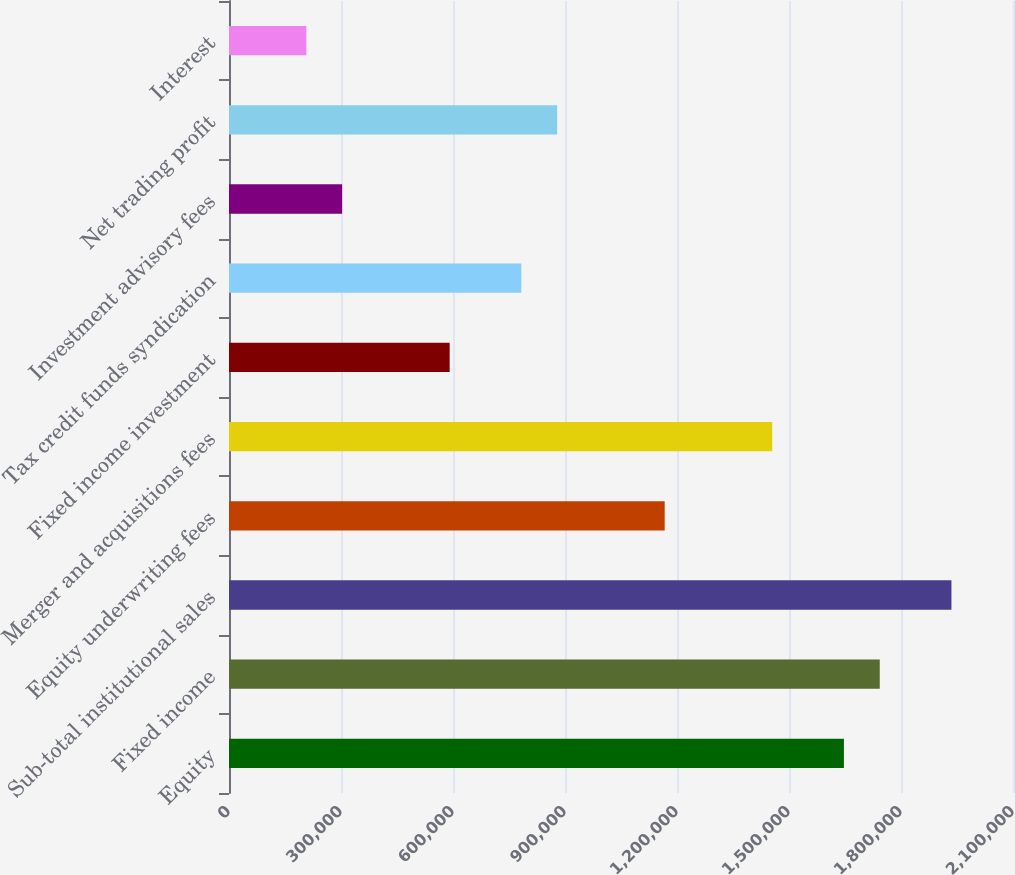Convert chart. <chart><loc_0><loc_0><loc_500><loc_500><bar_chart><fcel>Equity<fcel>Fixed income<fcel>Sub-total institutional sales<fcel>Equity underwriting fees<fcel>Merger and acquisitions fees<fcel>Fixed income investment<fcel>Tax credit funds syndication<fcel>Investment advisory fees<fcel>Net trading profit<fcel>Interest<nl><fcel>1.64709e+06<fcel>1.74309e+06<fcel>1.9351e+06<fcel>1.16707e+06<fcel>1.45508e+06<fcel>591050<fcel>783057<fcel>303040<fcel>879060<fcel>207036<nl></chart> 